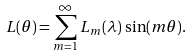Convert formula to latex. <formula><loc_0><loc_0><loc_500><loc_500>L ( \theta ) = \sum ^ { \infty } _ { m = 1 } L _ { m } ( \lambda ) \, \sin ( m \theta ) .</formula> 